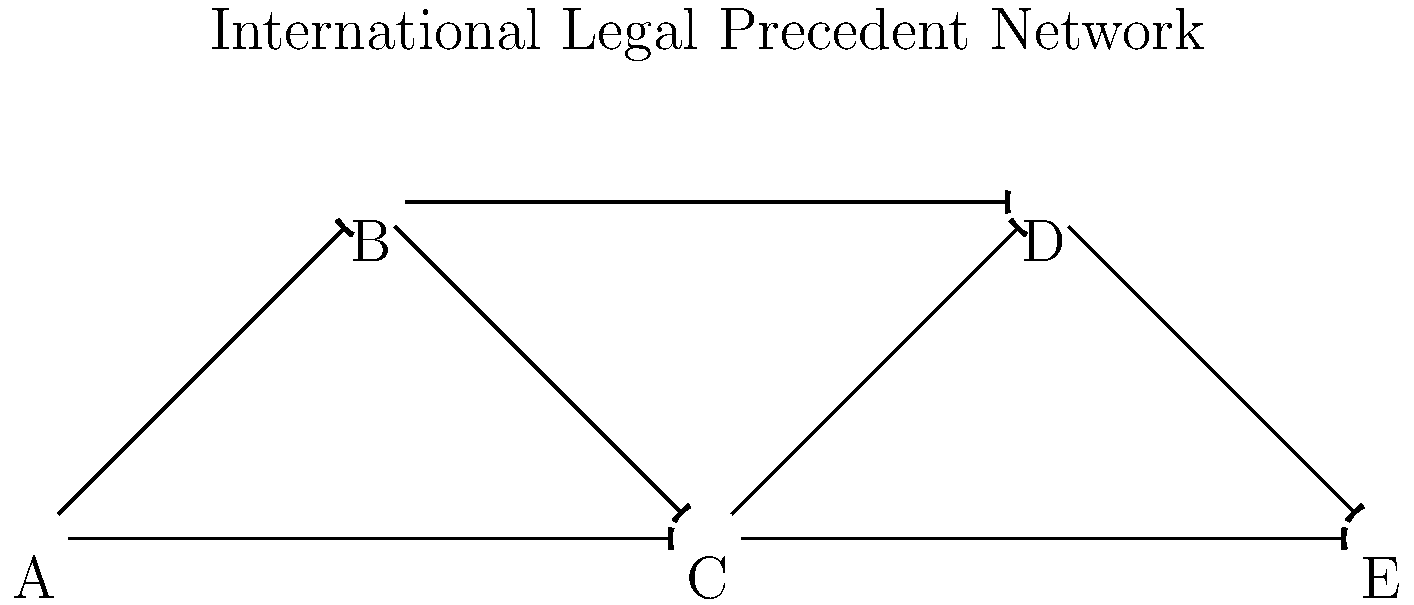Consider the network diagram representing the spread of international legal precedents across different jurisdictions (A, B, C, D, E). The rate of adoption of a legal precedent in jurisdiction $i$ is modeled by the differential equation:

$$\frac{dP_i}{dt} = k_i P_i (1 - P_i) + \sum_{j \neq i} \alpha_{ij} (P_j - P_i)$$

Where $P_i$ is the proportion of cases in jurisdiction $i$ that have adopted the precedent, $k_i$ is the internal adoption rate, and $\alpha_{ij}$ represents the influence of jurisdiction $j$ on jurisdiction $i$.

If we assume all $k_i = 0.5$ and all non-zero $\alpha_{ij} = 0.1$, what is the rate of change $\frac{dP_C}{dt}$ when $P_A = 0.8$, $P_B = 0.6$, $P_C = 0.4$, $P_D = 0.3$, and $P_E = 0.2$? Let's approach this step-by-step:

1) First, we need to identify which jurisdictions influence C directly. From the network diagram, we can see that A and B have arrows pointing to C.

2) Now, let's apply the given equation for jurisdiction C:

   $$\frac{dP_C}{dt} = k_C P_C (1 - P_C) + \alpha_{CA} (P_A - P_C) + \alpha_{CB} (P_B - P_C)$$

3) We're given that $k_C = 0.5$ and all non-zero $\alpha_{ij} = 0.1$. Let's substitute these values:

   $$\frac{dP_C}{dt} = 0.5 P_C (1 - P_C) + 0.1 (P_A - P_C) + 0.1 (P_B - P_C)$$

4) Now, let's substitute the given values for $P_A$, $P_B$, and $P_C$:

   $$\frac{dP_C}{dt} = 0.5 (0.4) (1 - 0.4) + 0.1 (0.8 - 0.4) + 0.1 (0.6 - 0.4)$$

5) Let's calculate each term:
   - $0.5 (0.4) (1 - 0.4) = 0.5 (0.4) (0.6) = 0.12$
   - $0.1 (0.8 - 0.4) = 0.1 (0.4) = 0.04$
   - $0.1 (0.6 - 0.4) = 0.1 (0.2) = 0.02$

6) Sum up all terms:

   $$\frac{dP_C}{dt} = 0.12 + 0.04 + 0.02 = 0.18$$
Answer: $\frac{dP_C}{dt} = 0.18$ 